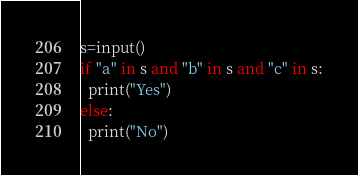<code> <loc_0><loc_0><loc_500><loc_500><_Python_>s=input()
if "a" in s and "b" in s and "c" in s:
  print("Yes")
else:
  print("No")</code> 